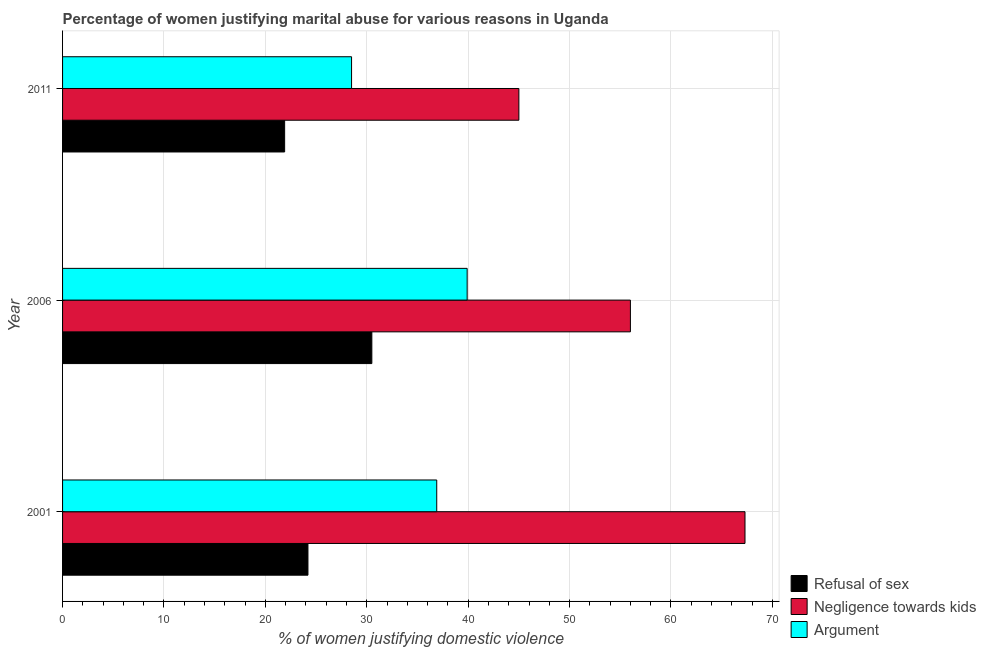How many groups of bars are there?
Ensure brevity in your answer.  3. Are the number of bars per tick equal to the number of legend labels?
Provide a short and direct response. Yes. Are the number of bars on each tick of the Y-axis equal?
Your answer should be very brief. Yes. What is the percentage of women justifying domestic violence due to refusal of sex in 2006?
Your response must be concise. 30.5. Across all years, what is the maximum percentage of women justifying domestic violence due to negligence towards kids?
Your answer should be very brief. 67.3. What is the total percentage of women justifying domestic violence due to negligence towards kids in the graph?
Provide a short and direct response. 168.3. What is the difference between the percentage of women justifying domestic violence due to refusal of sex in 2006 and that in 2011?
Offer a terse response. 8.6. What is the difference between the percentage of women justifying domestic violence due to refusal of sex in 2001 and the percentage of women justifying domestic violence due to arguments in 2011?
Your response must be concise. -4.3. What is the average percentage of women justifying domestic violence due to arguments per year?
Give a very brief answer. 35.1. What is the ratio of the percentage of women justifying domestic violence due to refusal of sex in 2006 to that in 2011?
Your answer should be compact. 1.39. Is the percentage of women justifying domestic violence due to negligence towards kids in 2006 less than that in 2011?
Offer a very short reply. No. Is the difference between the percentage of women justifying domestic violence due to arguments in 2001 and 2011 greater than the difference between the percentage of women justifying domestic violence due to negligence towards kids in 2001 and 2011?
Your answer should be compact. No. What is the difference between the highest and the second highest percentage of women justifying domestic violence due to arguments?
Give a very brief answer. 3. What is the difference between the highest and the lowest percentage of women justifying domestic violence due to arguments?
Offer a very short reply. 11.4. In how many years, is the percentage of women justifying domestic violence due to refusal of sex greater than the average percentage of women justifying domestic violence due to refusal of sex taken over all years?
Your answer should be compact. 1. Is the sum of the percentage of women justifying domestic violence due to refusal of sex in 2006 and 2011 greater than the maximum percentage of women justifying domestic violence due to arguments across all years?
Offer a terse response. Yes. What does the 1st bar from the top in 2001 represents?
Make the answer very short. Argument. What does the 2nd bar from the bottom in 2011 represents?
Make the answer very short. Negligence towards kids. Is it the case that in every year, the sum of the percentage of women justifying domestic violence due to refusal of sex and percentage of women justifying domestic violence due to negligence towards kids is greater than the percentage of women justifying domestic violence due to arguments?
Provide a succinct answer. Yes. How many bars are there?
Your answer should be very brief. 9. Are the values on the major ticks of X-axis written in scientific E-notation?
Provide a short and direct response. No. Does the graph contain any zero values?
Your response must be concise. No. How many legend labels are there?
Your answer should be compact. 3. What is the title of the graph?
Ensure brevity in your answer.  Percentage of women justifying marital abuse for various reasons in Uganda. Does "Ages 15-64" appear as one of the legend labels in the graph?
Your answer should be very brief. No. What is the label or title of the X-axis?
Give a very brief answer. % of women justifying domestic violence. What is the label or title of the Y-axis?
Offer a terse response. Year. What is the % of women justifying domestic violence of Refusal of sex in 2001?
Offer a very short reply. 24.2. What is the % of women justifying domestic violence in Negligence towards kids in 2001?
Provide a short and direct response. 67.3. What is the % of women justifying domestic violence of Argument in 2001?
Offer a very short reply. 36.9. What is the % of women justifying domestic violence of Refusal of sex in 2006?
Offer a very short reply. 30.5. What is the % of women justifying domestic violence of Argument in 2006?
Offer a terse response. 39.9. What is the % of women justifying domestic violence in Refusal of sex in 2011?
Keep it short and to the point. 21.9. What is the % of women justifying domestic violence of Negligence towards kids in 2011?
Ensure brevity in your answer.  45. What is the % of women justifying domestic violence in Argument in 2011?
Offer a terse response. 28.5. Across all years, what is the maximum % of women justifying domestic violence of Refusal of sex?
Keep it short and to the point. 30.5. Across all years, what is the maximum % of women justifying domestic violence in Negligence towards kids?
Make the answer very short. 67.3. Across all years, what is the maximum % of women justifying domestic violence of Argument?
Offer a very short reply. 39.9. Across all years, what is the minimum % of women justifying domestic violence of Refusal of sex?
Provide a succinct answer. 21.9. What is the total % of women justifying domestic violence in Refusal of sex in the graph?
Keep it short and to the point. 76.6. What is the total % of women justifying domestic violence in Negligence towards kids in the graph?
Your answer should be compact. 168.3. What is the total % of women justifying domestic violence in Argument in the graph?
Your answer should be very brief. 105.3. What is the difference between the % of women justifying domestic violence in Negligence towards kids in 2001 and that in 2006?
Your answer should be very brief. 11.3. What is the difference between the % of women justifying domestic violence in Refusal of sex in 2001 and that in 2011?
Provide a short and direct response. 2.3. What is the difference between the % of women justifying domestic violence in Negligence towards kids in 2001 and that in 2011?
Offer a very short reply. 22.3. What is the difference between the % of women justifying domestic violence in Argument in 2001 and that in 2011?
Make the answer very short. 8.4. What is the difference between the % of women justifying domestic violence of Refusal of sex in 2006 and that in 2011?
Your response must be concise. 8.6. What is the difference between the % of women justifying domestic violence in Argument in 2006 and that in 2011?
Ensure brevity in your answer.  11.4. What is the difference between the % of women justifying domestic violence of Refusal of sex in 2001 and the % of women justifying domestic violence of Negligence towards kids in 2006?
Give a very brief answer. -31.8. What is the difference between the % of women justifying domestic violence in Refusal of sex in 2001 and the % of women justifying domestic violence in Argument in 2006?
Keep it short and to the point. -15.7. What is the difference between the % of women justifying domestic violence in Negligence towards kids in 2001 and the % of women justifying domestic violence in Argument in 2006?
Make the answer very short. 27.4. What is the difference between the % of women justifying domestic violence in Refusal of sex in 2001 and the % of women justifying domestic violence in Negligence towards kids in 2011?
Keep it short and to the point. -20.8. What is the difference between the % of women justifying domestic violence in Negligence towards kids in 2001 and the % of women justifying domestic violence in Argument in 2011?
Keep it short and to the point. 38.8. What is the difference between the % of women justifying domestic violence of Refusal of sex in 2006 and the % of women justifying domestic violence of Negligence towards kids in 2011?
Offer a terse response. -14.5. What is the average % of women justifying domestic violence of Refusal of sex per year?
Your response must be concise. 25.53. What is the average % of women justifying domestic violence of Negligence towards kids per year?
Your response must be concise. 56.1. What is the average % of women justifying domestic violence of Argument per year?
Offer a very short reply. 35.1. In the year 2001, what is the difference between the % of women justifying domestic violence in Refusal of sex and % of women justifying domestic violence in Negligence towards kids?
Make the answer very short. -43.1. In the year 2001, what is the difference between the % of women justifying domestic violence of Negligence towards kids and % of women justifying domestic violence of Argument?
Provide a short and direct response. 30.4. In the year 2006, what is the difference between the % of women justifying domestic violence of Refusal of sex and % of women justifying domestic violence of Negligence towards kids?
Your answer should be compact. -25.5. In the year 2006, what is the difference between the % of women justifying domestic violence of Negligence towards kids and % of women justifying domestic violence of Argument?
Your answer should be very brief. 16.1. In the year 2011, what is the difference between the % of women justifying domestic violence of Refusal of sex and % of women justifying domestic violence of Negligence towards kids?
Make the answer very short. -23.1. In the year 2011, what is the difference between the % of women justifying domestic violence of Negligence towards kids and % of women justifying domestic violence of Argument?
Offer a terse response. 16.5. What is the ratio of the % of women justifying domestic violence of Refusal of sex in 2001 to that in 2006?
Provide a short and direct response. 0.79. What is the ratio of the % of women justifying domestic violence in Negligence towards kids in 2001 to that in 2006?
Your answer should be very brief. 1.2. What is the ratio of the % of women justifying domestic violence in Argument in 2001 to that in 2006?
Your response must be concise. 0.92. What is the ratio of the % of women justifying domestic violence in Refusal of sex in 2001 to that in 2011?
Keep it short and to the point. 1.1. What is the ratio of the % of women justifying domestic violence in Negligence towards kids in 2001 to that in 2011?
Make the answer very short. 1.5. What is the ratio of the % of women justifying domestic violence of Argument in 2001 to that in 2011?
Offer a very short reply. 1.29. What is the ratio of the % of women justifying domestic violence in Refusal of sex in 2006 to that in 2011?
Your answer should be compact. 1.39. What is the ratio of the % of women justifying domestic violence of Negligence towards kids in 2006 to that in 2011?
Provide a succinct answer. 1.24. What is the difference between the highest and the second highest % of women justifying domestic violence of Refusal of sex?
Provide a short and direct response. 6.3. What is the difference between the highest and the second highest % of women justifying domestic violence in Negligence towards kids?
Your answer should be compact. 11.3. What is the difference between the highest and the second highest % of women justifying domestic violence of Argument?
Offer a very short reply. 3. What is the difference between the highest and the lowest % of women justifying domestic violence of Refusal of sex?
Provide a succinct answer. 8.6. What is the difference between the highest and the lowest % of women justifying domestic violence of Negligence towards kids?
Provide a short and direct response. 22.3. 